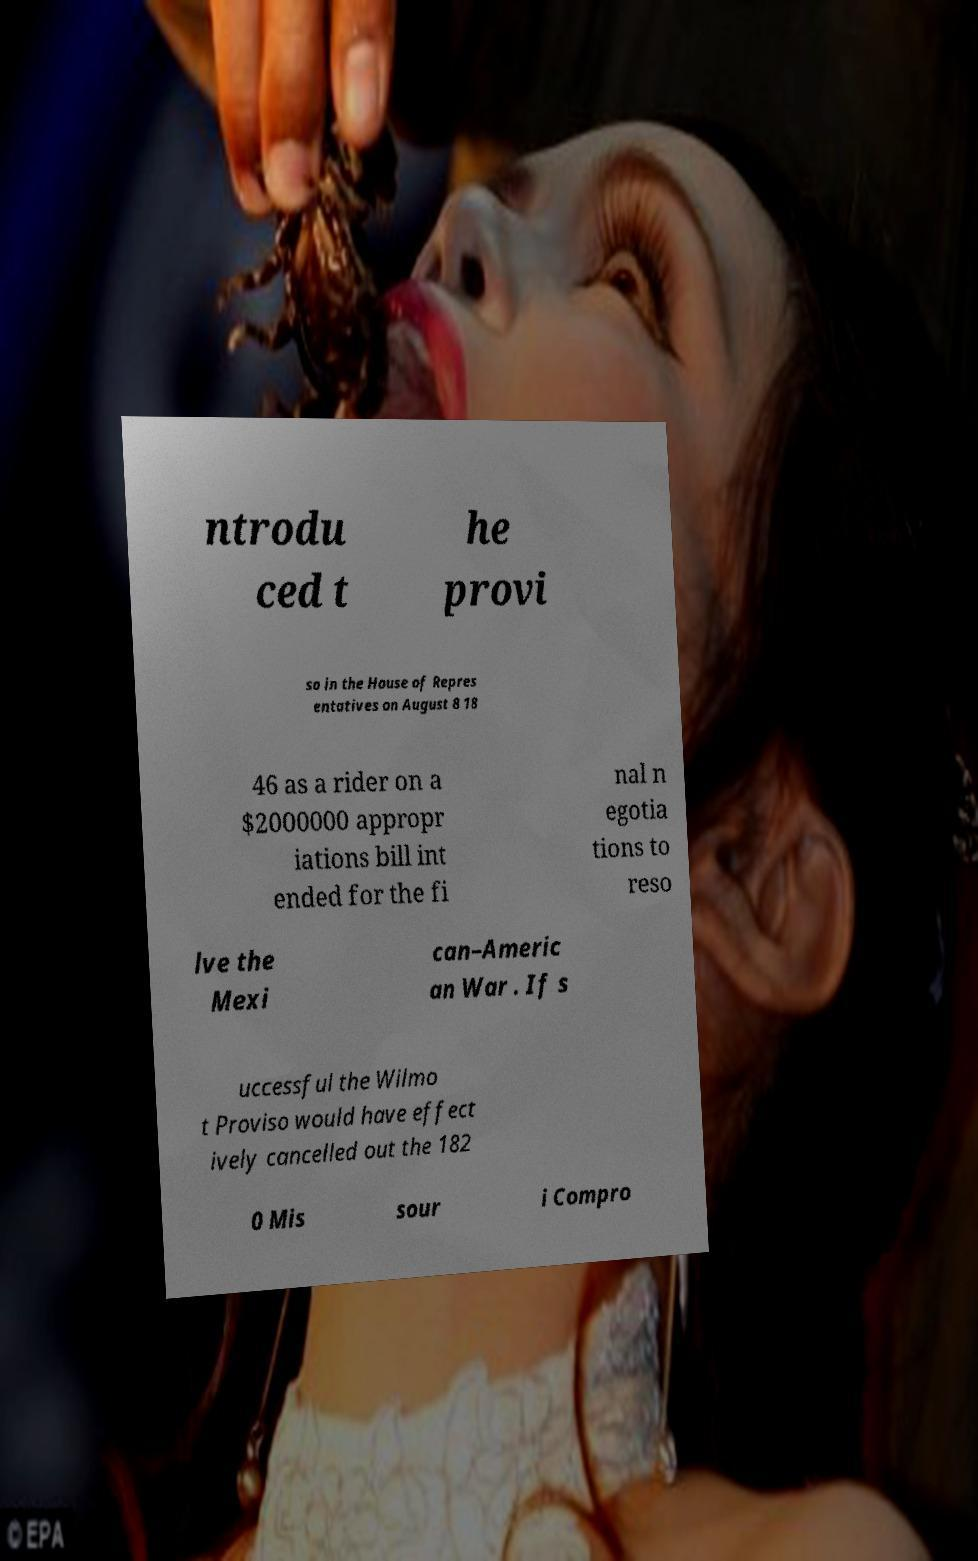Could you extract and type out the text from this image? ntrodu ced t he provi so in the House of Repres entatives on August 8 18 46 as a rider on a $2000000 appropr iations bill int ended for the fi nal n egotia tions to reso lve the Mexi can–Americ an War . If s uccessful the Wilmo t Proviso would have effect ively cancelled out the 182 0 Mis sour i Compro 